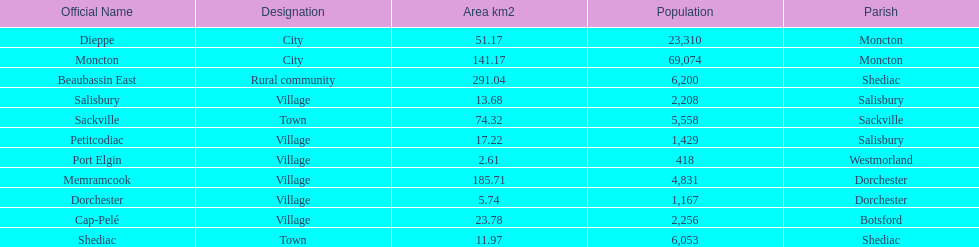Which municipality has the most number of people who reside in it? Moncton. 